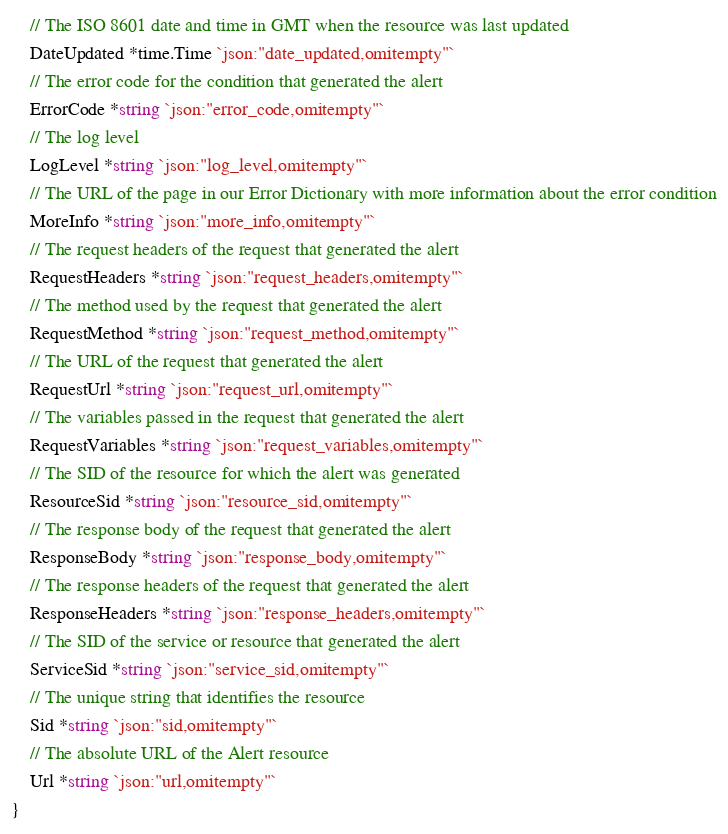Convert code to text. <code><loc_0><loc_0><loc_500><loc_500><_Go_>	// The ISO 8601 date and time in GMT when the resource was last updated
	DateUpdated *time.Time `json:"date_updated,omitempty"`
	// The error code for the condition that generated the alert
	ErrorCode *string `json:"error_code,omitempty"`
	// The log level
	LogLevel *string `json:"log_level,omitempty"`
	// The URL of the page in our Error Dictionary with more information about the error condition
	MoreInfo *string `json:"more_info,omitempty"`
	// The request headers of the request that generated the alert
	RequestHeaders *string `json:"request_headers,omitempty"`
	// The method used by the request that generated the alert
	RequestMethod *string `json:"request_method,omitempty"`
	// The URL of the request that generated the alert
	RequestUrl *string `json:"request_url,omitempty"`
	// The variables passed in the request that generated the alert
	RequestVariables *string `json:"request_variables,omitempty"`
	// The SID of the resource for which the alert was generated
	ResourceSid *string `json:"resource_sid,omitempty"`
	// The response body of the request that generated the alert
	ResponseBody *string `json:"response_body,omitempty"`
	// The response headers of the request that generated the alert
	ResponseHeaders *string `json:"response_headers,omitempty"`
	// The SID of the service or resource that generated the alert
	ServiceSid *string `json:"service_sid,omitempty"`
	// The unique string that identifies the resource
	Sid *string `json:"sid,omitempty"`
	// The absolute URL of the Alert resource
	Url *string `json:"url,omitempty"`
}
</code> 